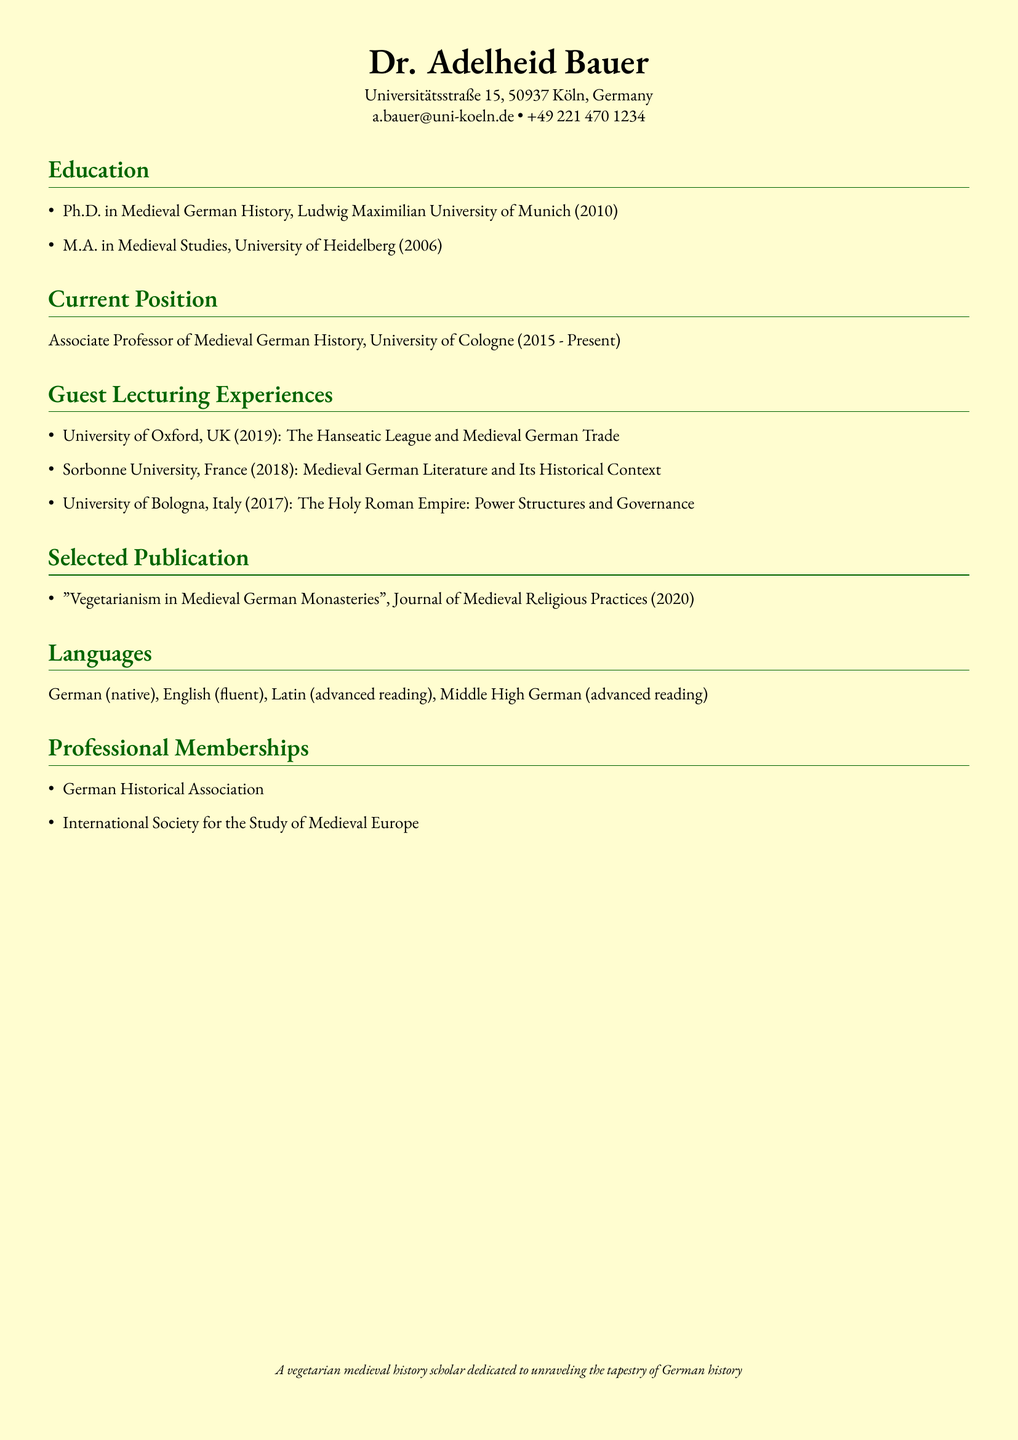What is Dr. Adelheid Bauer's email address? The email address is explicitly stated in the personal information section of the document.
Answer: a.bauer@uni-koeln.de In what year did Dr. Bauer complete her Ph.D.? The year of completing the Ph.D. degree is clearly mentioned in the education section.
Answer: 2010 Which university does Dr. Bauer currently work at? The current institution where Dr. Bauer serves is stated under the current position section.
Answer: University of Cologne What topic did Dr. Bauer lecture on at Sorbonne University? The document specifies the topic of guest lecturing at Sorbonne University listed under guest lecturing experiences.
Answer: Medieval German Literature and Its Historical Context How many languages can Dr. Bauer speak? The languages section lists all the languages Dr. Bauer can speak, allowing for a simple count.
Answer: 4 What is the title of Dr. Bauer's publication? The publication title is provided in the selected publication section of the resume.
Answer: Vegetarianism in Medieval German Monasteries When did Dr. Bauer guest lecture at the University of Bologna? The specific year of guest lecturing at the University of Bologna is stated in the guest lecturing experiences.
Answer: 2017 Which professional membership is Dr. Bauer a part of? The document lists memberships in associations, indicating her professional affiliations.
Answer: German Historical Association What is Dr. Bauer's current position title? The title of Dr. Bauer's current position is mentioned in the current position section of the document.
Answer: Associate Professor of Medieval German History 